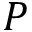<formula> <loc_0><loc_0><loc_500><loc_500>P</formula> 